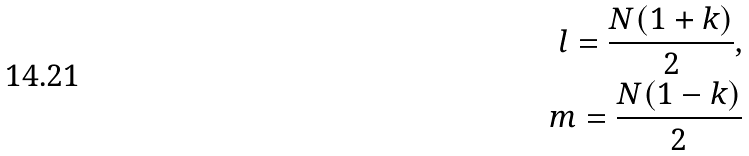<formula> <loc_0><loc_0><loc_500><loc_500>l = \frac { N ( 1 + k ) } { 2 } , \\ m = \frac { N ( 1 - k ) } { 2 }</formula> 